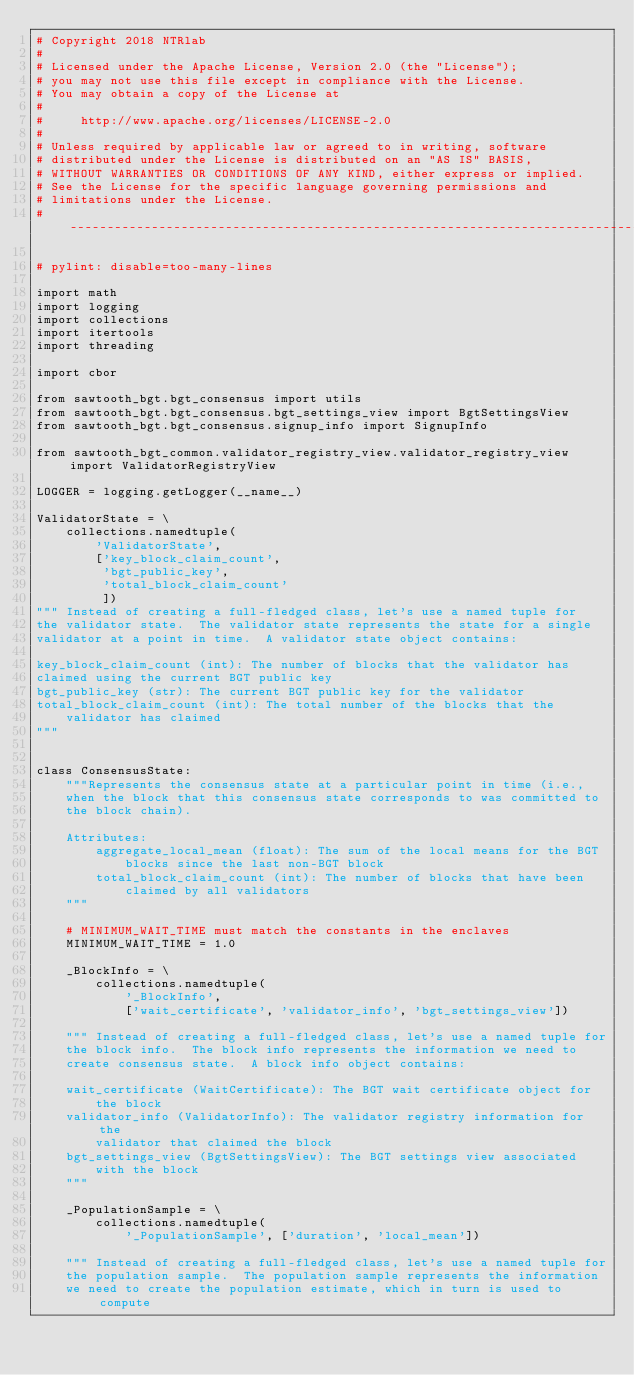Convert code to text. <code><loc_0><loc_0><loc_500><loc_500><_Python_># Copyright 2018 NTRlab
#
# Licensed under the Apache License, Version 2.0 (the "License");
# you may not use this file except in compliance with the License.
# You may obtain a copy of the License at
#
#     http://www.apache.org/licenses/LICENSE-2.0
#
# Unless required by applicable law or agreed to in writing, software
# distributed under the License is distributed on an "AS IS" BASIS,
# WITHOUT WARRANTIES OR CONDITIONS OF ANY KIND, either express or implied.
# See the License for the specific language governing permissions and
# limitations under the License.
# ------------------------------------------------------------------------------

# pylint: disable=too-many-lines

import math
import logging
import collections
import itertools
import threading

import cbor

from sawtooth_bgt.bgt_consensus import utils
from sawtooth_bgt.bgt_consensus.bgt_settings_view import BgtSettingsView
from sawtooth_bgt.bgt_consensus.signup_info import SignupInfo

from sawtooth_bgt_common.validator_registry_view.validator_registry_view import ValidatorRegistryView

LOGGER = logging.getLogger(__name__)

ValidatorState = \
    collections.namedtuple(
        'ValidatorState',
        ['key_block_claim_count',
         'bgt_public_key',
         'total_block_claim_count'
         ])
""" Instead of creating a full-fledged class, let's use a named tuple for
the validator state.  The validator state represents the state for a single
validator at a point in time.  A validator state object contains:

key_block_claim_count (int): The number of blocks that the validator has
claimed using the current BGT public key
bgt_public_key (str): The current BGT public key for the validator
total_block_claim_count (int): The total number of the blocks that the
    validator has claimed
"""


class ConsensusState:
    """Represents the consensus state at a particular point in time (i.e.,
    when the block that this consensus state corresponds to was committed to
    the block chain).

    Attributes:
        aggregate_local_mean (float): The sum of the local means for the BGT
            blocks since the last non-BGT block
        total_block_claim_count (int): The number of blocks that have been
            claimed by all validators
    """

    # MINIMUM_WAIT_TIME must match the constants in the enclaves
    MINIMUM_WAIT_TIME = 1.0

    _BlockInfo = \
        collections.namedtuple(
            '_BlockInfo',
            ['wait_certificate', 'validator_info', 'bgt_settings_view'])

    """ Instead of creating a full-fledged class, let's use a named tuple for
    the block info.  The block info represents the information we need to
    create consensus state.  A block info object contains:

    wait_certificate (WaitCertificate): The BGT wait certificate object for
        the block
    validator_info (ValidatorInfo): The validator registry information for the
        validator that claimed the block
    bgt_settings_view (BgtSettingsView): The BGT settings view associated
        with the block
    """

    _PopulationSample = \
        collections.namedtuple(
            '_PopulationSample', ['duration', 'local_mean'])

    """ Instead of creating a full-fledged class, let's use a named tuple for
    the population sample.  The population sample represents the information
    we need to create the population estimate, which in turn is used to compute</code> 